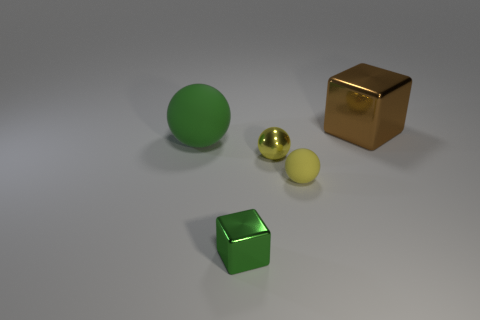What is the material of the large thing that is to the right of the big thing that is in front of the large metallic block?
Offer a very short reply. Metal. How many large brown objects have the same shape as the tiny green shiny thing?
Make the answer very short. 1. The big rubber thing is what shape?
Give a very brief answer. Sphere. Are there fewer small blue metallic objects than metal balls?
Make the answer very short. Yes. Is there anything else that has the same size as the brown metal thing?
Give a very brief answer. Yes. What material is the other object that is the same shape as the big brown metallic thing?
Provide a succinct answer. Metal. Are there more purple metallic cylinders than small yellow objects?
Your response must be concise. No. How many other objects are there of the same color as the big metallic thing?
Provide a succinct answer. 0. Is the brown object made of the same material as the yellow thing that is behind the yellow rubber ball?
Your response must be concise. Yes. How many brown blocks are in front of the green object left of the block that is to the left of the tiny yellow rubber sphere?
Ensure brevity in your answer.  0. 